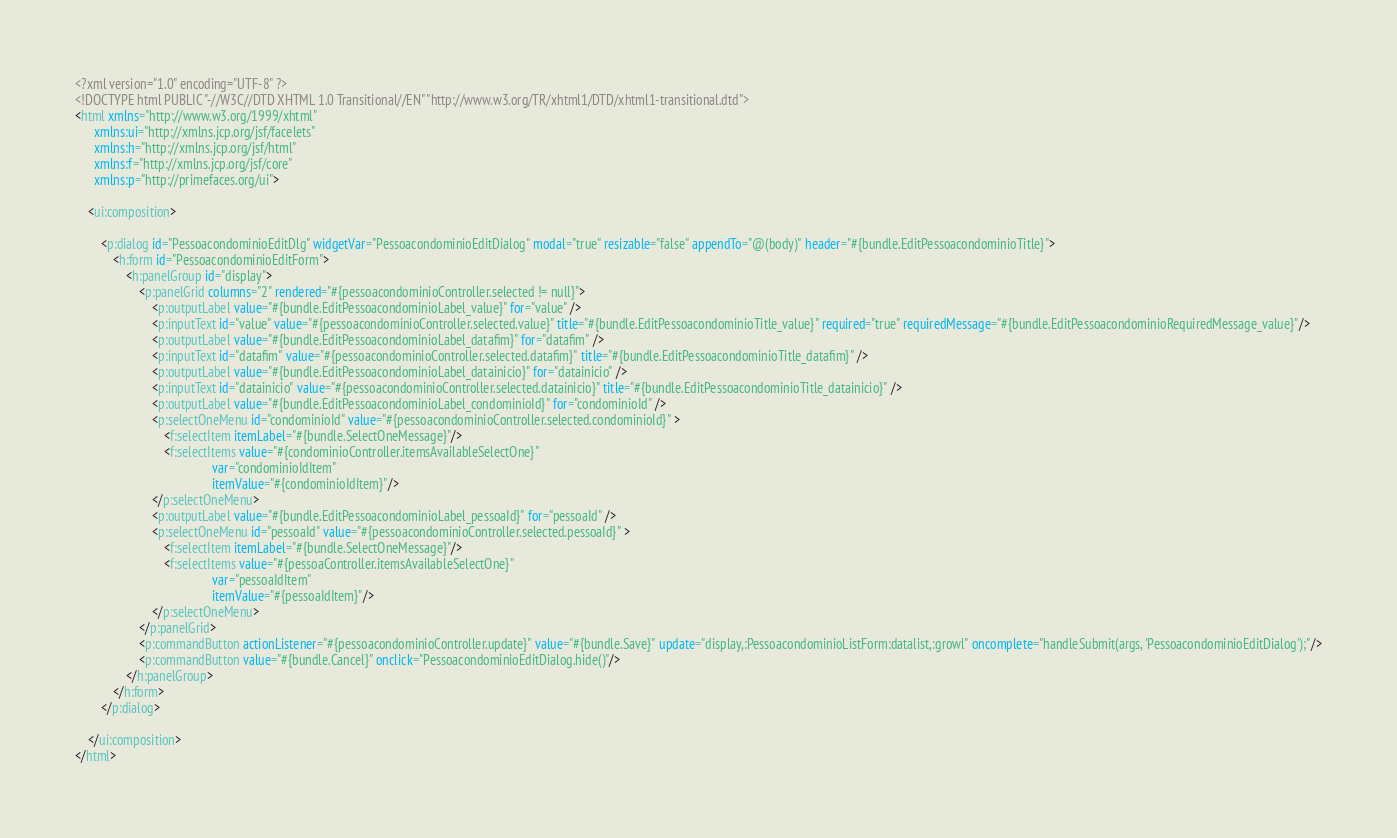Convert code to text. <code><loc_0><loc_0><loc_500><loc_500><_HTML_><?xml version="1.0" encoding="UTF-8" ?>
<!DOCTYPE html PUBLIC "-//W3C//DTD XHTML 1.0 Transitional//EN" "http://www.w3.org/TR/xhtml1/DTD/xhtml1-transitional.dtd">
<html xmlns="http://www.w3.org/1999/xhtml"
      xmlns:ui="http://xmlns.jcp.org/jsf/facelets"
      xmlns:h="http://xmlns.jcp.org/jsf/html"
      xmlns:f="http://xmlns.jcp.org/jsf/core"
      xmlns:p="http://primefaces.org/ui">

    <ui:composition>

        <p:dialog id="PessoacondominioEditDlg" widgetVar="PessoacondominioEditDialog" modal="true" resizable="false" appendTo="@(body)" header="#{bundle.EditPessoacondominioTitle}">
            <h:form id="PessoacondominioEditForm">
                <h:panelGroup id="display">
                    <p:panelGrid columns="2" rendered="#{pessoacondominioController.selected != null}">
                        <p:outputLabel value="#{bundle.EditPessoacondominioLabel_value}" for="value" />
                        <p:inputText id="value" value="#{pessoacondominioController.selected.value}" title="#{bundle.EditPessoacondominioTitle_value}" required="true" requiredMessage="#{bundle.EditPessoacondominioRequiredMessage_value}"/>
                        <p:outputLabel value="#{bundle.EditPessoacondominioLabel_datafim}" for="datafim" />
                        <p:inputText id="datafim" value="#{pessoacondominioController.selected.datafim}" title="#{bundle.EditPessoacondominioTitle_datafim}" />
                        <p:outputLabel value="#{bundle.EditPessoacondominioLabel_datainicio}" for="datainicio" />
                        <p:inputText id="datainicio" value="#{pessoacondominioController.selected.datainicio}" title="#{bundle.EditPessoacondominioTitle_datainicio}" />
                        <p:outputLabel value="#{bundle.EditPessoacondominioLabel_condominioId}" for="condominioId" />
                        <p:selectOneMenu id="condominioId" value="#{pessoacondominioController.selected.condominioId}" >
                            <f:selectItem itemLabel="#{bundle.SelectOneMessage}"/>
                            <f:selectItems value="#{condominioController.itemsAvailableSelectOne}"
                                           var="condominioIdItem"
                                           itemValue="#{condominioIdItem}"/>
                        </p:selectOneMenu>
                        <p:outputLabel value="#{bundle.EditPessoacondominioLabel_pessoaId}" for="pessoaId" />
                        <p:selectOneMenu id="pessoaId" value="#{pessoacondominioController.selected.pessoaId}" >
                            <f:selectItem itemLabel="#{bundle.SelectOneMessage}"/>
                            <f:selectItems value="#{pessoaController.itemsAvailableSelectOne}"
                                           var="pessoaIdItem"
                                           itemValue="#{pessoaIdItem}"/>
                        </p:selectOneMenu>
                    </p:panelGrid>
                    <p:commandButton actionListener="#{pessoacondominioController.update}" value="#{bundle.Save}" update="display,:PessoacondominioListForm:datalist,:growl" oncomplete="handleSubmit(args, 'PessoacondominioEditDialog');"/>
                    <p:commandButton value="#{bundle.Cancel}" onclick="PessoacondominioEditDialog.hide()"/>
                </h:panelGroup>
            </h:form>
        </p:dialog>

    </ui:composition>
</html>
</code> 